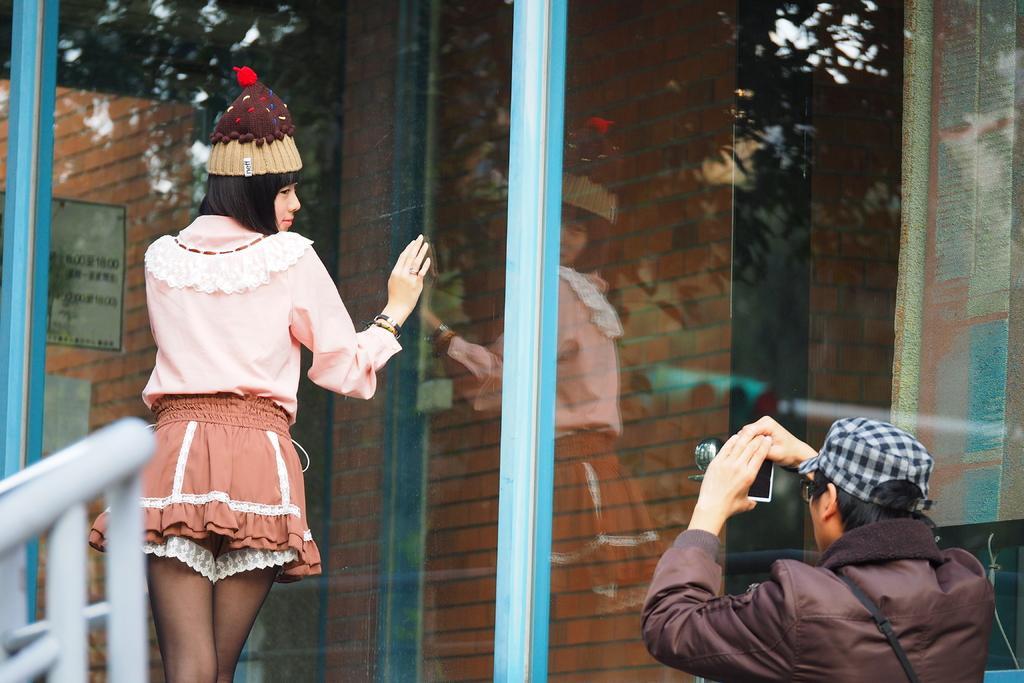Please provide a concise description of this image. In this picture there is a person wearing hat is holding a camera in his hands in the right corner and there is a woman standing in front of him and there is a glass beside her and there are few iron rods in the left corner. 